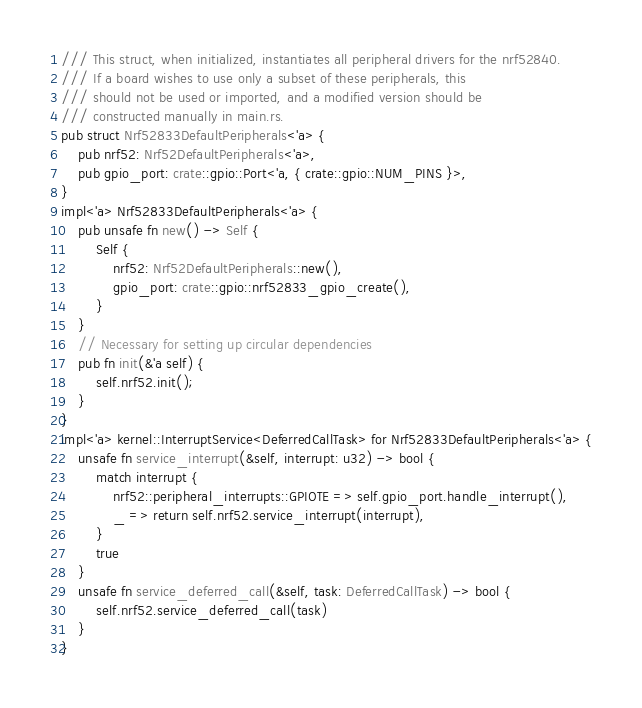<code> <loc_0><loc_0><loc_500><loc_500><_Rust_>/// This struct, when initialized, instantiates all peripheral drivers for the nrf52840.
/// If a board wishes to use only a subset of these peripherals, this
/// should not be used or imported, and a modified version should be
/// constructed manually in main.rs.
pub struct Nrf52833DefaultPeripherals<'a> {
    pub nrf52: Nrf52DefaultPeripherals<'a>,
    pub gpio_port: crate::gpio::Port<'a, { crate::gpio::NUM_PINS }>,
}
impl<'a> Nrf52833DefaultPeripherals<'a> {
    pub unsafe fn new() -> Self {
        Self {
            nrf52: Nrf52DefaultPeripherals::new(),
            gpio_port: crate::gpio::nrf52833_gpio_create(),
        }
    }
    // Necessary for setting up circular dependencies
    pub fn init(&'a self) {
        self.nrf52.init();
    }
}
impl<'a> kernel::InterruptService<DeferredCallTask> for Nrf52833DefaultPeripherals<'a> {
    unsafe fn service_interrupt(&self, interrupt: u32) -> bool {
        match interrupt {
            nrf52::peripheral_interrupts::GPIOTE => self.gpio_port.handle_interrupt(),
            _ => return self.nrf52.service_interrupt(interrupt),
        }
        true
    }
    unsafe fn service_deferred_call(&self, task: DeferredCallTask) -> bool {
        self.nrf52.service_deferred_call(task)
    }
}
</code> 